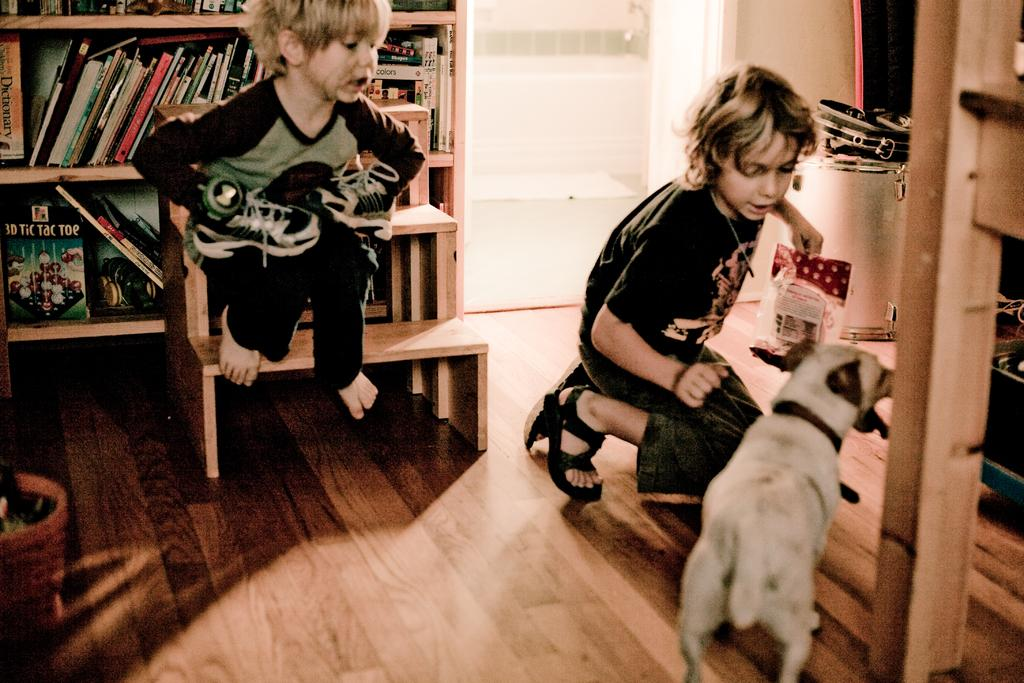How many children are present in the image? There are two children in the image. What can be seen on the shelves in the image? There are books on the shelves in the image. What type of animal is present in the image? There is a dog in the image. Can you describe any other objects in the image? There are some other objects in the image, but their specific details are not mentioned in the provided facts. What type of account is the dog opening in the image? There is no account present in the image; it features two children, books on shelves, and a dog. What type of smile can be seen on the children's faces in the image? The provided facts do not mention the children's facial expressions, so it is not possible to determine if they are smiling or not. 